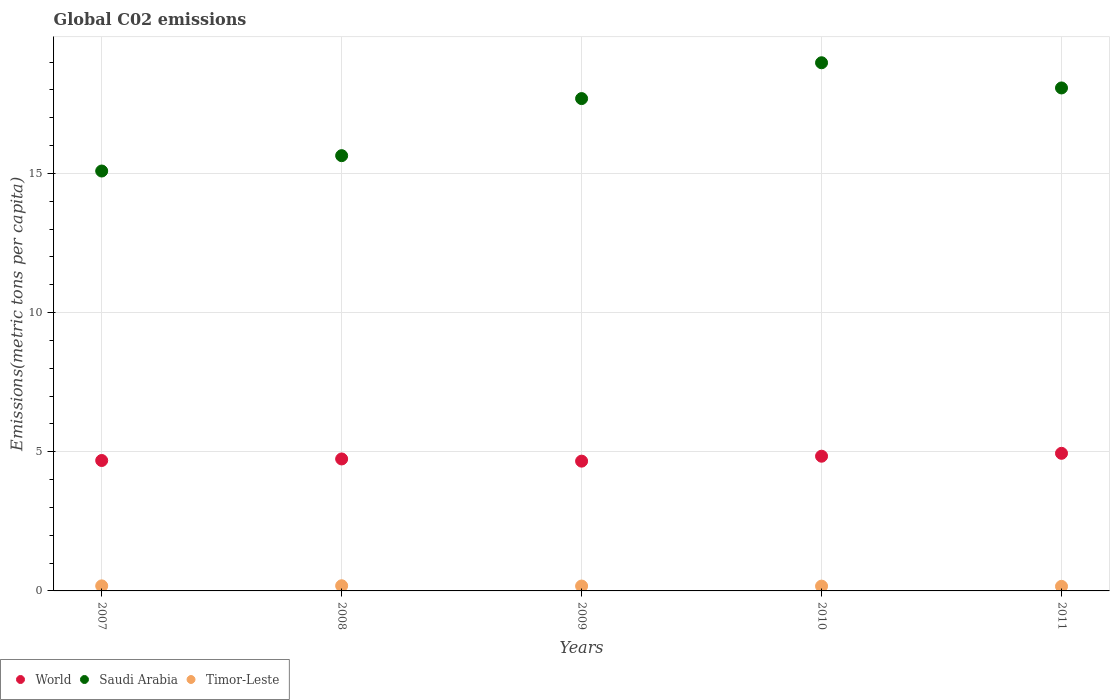How many different coloured dotlines are there?
Offer a very short reply. 3. Is the number of dotlines equal to the number of legend labels?
Make the answer very short. Yes. What is the amount of CO2 emitted in in World in 2009?
Give a very brief answer. 4.66. Across all years, what is the maximum amount of CO2 emitted in in World?
Ensure brevity in your answer.  4.94. Across all years, what is the minimum amount of CO2 emitted in in Saudi Arabia?
Your answer should be compact. 15.09. What is the total amount of CO2 emitted in in World in the graph?
Give a very brief answer. 23.88. What is the difference between the amount of CO2 emitted in in Saudi Arabia in 2007 and that in 2009?
Provide a succinct answer. -2.6. What is the difference between the amount of CO2 emitted in in Saudi Arabia in 2011 and the amount of CO2 emitted in in Timor-Leste in 2007?
Your answer should be compact. 17.89. What is the average amount of CO2 emitted in in Saudi Arabia per year?
Provide a short and direct response. 17.09. In the year 2007, what is the difference between the amount of CO2 emitted in in Saudi Arabia and amount of CO2 emitted in in Timor-Leste?
Offer a terse response. 14.91. In how many years, is the amount of CO2 emitted in in World greater than 4 metric tons per capita?
Your answer should be compact. 5. What is the ratio of the amount of CO2 emitted in in Saudi Arabia in 2008 to that in 2009?
Your answer should be very brief. 0.88. What is the difference between the highest and the second highest amount of CO2 emitted in in World?
Your answer should be very brief. 0.1. What is the difference between the highest and the lowest amount of CO2 emitted in in Timor-Leste?
Keep it short and to the point. 0.02. How many dotlines are there?
Your response must be concise. 3. Are the values on the major ticks of Y-axis written in scientific E-notation?
Make the answer very short. No. Does the graph contain any zero values?
Give a very brief answer. No. Does the graph contain grids?
Ensure brevity in your answer.  Yes. How many legend labels are there?
Offer a terse response. 3. How are the legend labels stacked?
Your answer should be compact. Horizontal. What is the title of the graph?
Your response must be concise. Global C02 emissions. What is the label or title of the X-axis?
Offer a terse response. Years. What is the label or title of the Y-axis?
Offer a very short reply. Emissions(metric tons per capita). What is the Emissions(metric tons per capita) in World in 2007?
Offer a terse response. 4.69. What is the Emissions(metric tons per capita) of Saudi Arabia in 2007?
Your answer should be compact. 15.09. What is the Emissions(metric tons per capita) in Timor-Leste in 2007?
Provide a succinct answer. 0.18. What is the Emissions(metric tons per capita) of World in 2008?
Offer a very short reply. 4.74. What is the Emissions(metric tons per capita) of Saudi Arabia in 2008?
Make the answer very short. 15.64. What is the Emissions(metric tons per capita) in Timor-Leste in 2008?
Offer a terse response. 0.19. What is the Emissions(metric tons per capita) of World in 2009?
Provide a short and direct response. 4.66. What is the Emissions(metric tons per capita) in Saudi Arabia in 2009?
Provide a short and direct response. 17.69. What is the Emissions(metric tons per capita) of Timor-Leste in 2009?
Keep it short and to the point. 0.17. What is the Emissions(metric tons per capita) in World in 2010?
Give a very brief answer. 4.84. What is the Emissions(metric tons per capita) of Saudi Arabia in 2010?
Ensure brevity in your answer.  18.98. What is the Emissions(metric tons per capita) in Timor-Leste in 2010?
Your answer should be compact. 0.17. What is the Emissions(metric tons per capita) of World in 2011?
Your answer should be compact. 4.94. What is the Emissions(metric tons per capita) in Saudi Arabia in 2011?
Offer a very short reply. 18.07. What is the Emissions(metric tons per capita) of Timor-Leste in 2011?
Ensure brevity in your answer.  0.16. Across all years, what is the maximum Emissions(metric tons per capita) in World?
Provide a short and direct response. 4.94. Across all years, what is the maximum Emissions(metric tons per capita) in Saudi Arabia?
Offer a terse response. 18.98. Across all years, what is the maximum Emissions(metric tons per capita) in Timor-Leste?
Provide a short and direct response. 0.19. Across all years, what is the minimum Emissions(metric tons per capita) of World?
Make the answer very short. 4.66. Across all years, what is the minimum Emissions(metric tons per capita) of Saudi Arabia?
Keep it short and to the point. 15.09. Across all years, what is the minimum Emissions(metric tons per capita) of Timor-Leste?
Ensure brevity in your answer.  0.16. What is the total Emissions(metric tons per capita) of World in the graph?
Keep it short and to the point. 23.88. What is the total Emissions(metric tons per capita) of Saudi Arabia in the graph?
Your answer should be very brief. 85.47. What is the total Emissions(metric tons per capita) of Timor-Leste in the graph?
Give a very brief answer. 0.88. What is the difference between the Emissions(metric tons per capita) of World in 2007 and that in 2008?
Your response must be concise. -0.06. What is the difference between the Emissions(metric tons per capita) of Saudi Arabia in 2007 and that in 2008?
Provide a succinct answer. -0.55. What is the difference between the Emissions(metric tons per capita) in Timor-Leste in 2007 and that in 2008?
Offer a terse response. -0. What is the difference between the Emissions(metric tons per capita) in World in 2007 and that in 2009?
Give a very brief answer. 0.02. What is the difference between the Emissions(metric tons per capita) of Saudi Arabia in 2007 and that in 2009?
Give a very brief answer. -2.6. What is the difference between the Emissions(metric tons per capita) in Timor-Leste in 2007 and that in 2009?
Make the answer very short. 0.01. What is the difference between the Emissions(metric tons per capita) in World in 2007 and that in 2010?
Offer a terse response. -0.15. What is the difference between the Emissions(metric tons per capita) of Saudi Arabia in 2007 and that in 2010?
Give a very brief answer. -3.89. What is the difference between the Emissions(metric tons per capita) of Timor-Leste in 2007 and that in 2010?
Provide a short and direct response. 0.01. What is the difference between the Emissions(metric tons per capita) of World in 2007 and that in 2011?
Make the answer very short. -0.26. What is the difference between the Emissions(metric tons per capita) of Saudi Arabia in 2007 and that in 2011?
Provide a succinct answer. -2.98. What is the difference between the Emissions(metric tons per capita) of Timor-Leste in 2007 and that in 2011?
Provide a succinct answer. 0.02. What is the difference between the Emissions(metric tons per capita) in World in 2008 and that in 2009?
Offer a very short reply. 0.08. What is the difference between the Emissions(metric tons per capita) in Saudi Arabia in 2008 and that in 2009?
Give a very brief answer. -2.05. What is the difference between the Emissions(metric tons per capita) in Timor-Leste in 2008 and that in 2009?
Your answer should be very brief. 0.01. What is the difference between the Emissions(metric tons per capita) of World in 2008 and that in 2010?
Ensure brevity in your answer.  -0.1. What is the difference between the Emissions(metric tons per capita) in Saudi Arabia in 2008 and that in 2010?
Your answer should be very brief. -3.34. What is the difference between the Emissions(metric tons per capita) of Timor-Leste in 2008 and that in 2010?
Offer a very short reply. 0.01. What is the difference between the Emissions(metric tons per capita) in World in 2008 and that in 2011?
Make the answer very short. -0.2. What is the difference between the Emissions(metric tons per capita) of Saudi Arabia in 2008 and that in 2011?
Offer a very short reply. -2.43. What is the difference between the Emissions(metric tons per capita) in Timor-Leste in 2008 and that in 2011?
Keep it short and to the point. 0.02. What is the difference between the Emissions(metric tons per capita) of World in 2009 and that in 2010?
Ensure brevity in your answer.  -0.18. What is the difference between the Emissions(metric tons per capita) of Saudi Arabia in 2009 and that in 2010?
Provide a short and direct response. -1.29. What is the difference between the Emissions(metric tons per capita) in Timor-Leste in 2009 and that in 2010?
Your answer should be compact. 0. What is the difference between the Emissions(metric tons per capita) of World in 2009 and that in 2011?
Provide a succinct answer. -0.28. What is the difference between the Emissions(metric tons per capita) of Saudi Arabia in 2009 and that in 2011?
Your response must be concise. -0.38. What is the difference between the Emissions(metric tons per capita) of Timor-Leste in 2009 and that in 2011?
Make the answer very short. 0.01. What is the difference between the Emissions(metric tons per capita) in World in 2010 and that in 2011?
Offer a very short reply. -0.1. What is the difference between the Emissions(metric tons per capita) in Saudi Arabia in 2010 and that in 2011?
Ensure brevity in your answer.  0.91. What is the difference between the Emissions(metric tons per capita) in Timor-Leste in 2010 and that in 2011?
Make the answer very short. 0.01. What is the difference between the Emissions(metric tons per capita) in World in 2007 and the Emissions(metric tons per capita) in Saudi Arabia in 2008?
Give a very brief answer. -10.95. What is the difference between the Emissions(metric tons per capita) in World in 2007 and the Emissions(metric tons per capita) in Timor-Leste in 2008?
Your response must be concise. 4.5. What is the difference between the Emissions(metric tons per capita) in Saudi Arabia in 2007 and the Emissions(metric tons per capita) in Timor-Leste in 2008?
Your response must be concise. 14.9. What is the difference between the Emissions(metric tons per capita) of World in 2007 and the Emissions(metric tons per capita) of Saudi Arabia in 2009?
Make the answer very short. -13. What is the difference between the Emissions(metric tons per capita) in World in 2007 and the Emissions(metric tons per capita) in Timor-Leste in 2009?
Provide a short and direct response. 4.51. What is the difference between the Emissions(metric tons per capita) in Saudi Arabia in 2007 and the Emissions(metric tons per capita) in Timor-Leste in 2009?
Keep it short and to the point. 14.91. What is the difference between the Emissions(metric tons per capita) of World in 2007 and the Emissions(metric tons per capita) of Saudi Arabia in 2010?
Make the answer very short. -14.29. What is the difference between the Emissions(metric tons per capita) of World in 2007 and the Emissions(metric tons per capita) of Timor-Leste in 2010?
Provide a succinct answer. 4.51. What is the difference between the Emissions(metric tons per capita) in Saudi Arabia in 2007 and the Emissions(metric tons per capita) in Timor-Leste in 2010?
Your response must be concise. 14.92. What is the difference between the Emissions(metric tons per capita) in World in 2007 and the Emissions(metric tons per capita) in Saudi Arabia in 2011?
Your response must be concise. -13.39. What is the difference between the Emissions(metric tons per capita) in World in 2007 and the Emissions(metric tons per capita) in Timor-Leste in 2011?
Ensure brevity in your answer.  4.52. What is the difference between the Emissions(metric tons per capita) of Saudi Arabia in 2007 and the Emissions(metric tons per capita) of Timor-Leste in 2011?
Ensure brevity in your answer.  14.92. What is the difference between the Emissions(metric tons per capita) in World in 2008 and the Emissions(metric tons per capita) in Saudi Arabia in 2009?
Make the answer very short. -12.95. What is the difference between the Emissions(metric tons per capita) of World in 2008 and the Emissions(metric tons per capita) of Timor-Leste in 2009?
Ensure brevity in your answer.  4.57. What is the difference between the Emissions(metric tons per capita) in Saudi Arabia in 2008 and the Emissions(metric tons per capita) in Timor-Leste in 2009?
Ensure brevity in your answer.  15.46. What is the difference between the Emissions(metric tons per capita) of World in 2008 and the Emissions(metric tons per capita) of Saudi Arabia in 2010?
Your answer should be very brief. -14.24. What is the difference between the Emissions(metric tons per capita) of World in 2008 and the Emissions(metric tons per capita) of Timor-Leste in 2010?
Make the answer very short. 4.57. What is the difference between the Emissions(metric tons per capita) in Saudi Arabia in 2008 and the Emissions(metric tons per capita) in Timor-Leste in 2010?
Make the answer very short. 15.47. What is the difference between the Emissions(metric tons per capita) of World in 2008 and the Emissions(metric tons per capita) of Saudi Arabia in 2011?
Your answer should be compact. -13.33. What is the difference between the Emissions(metric tons per capita) of World in 2008 and the Emissions(metric tons per capita) of Timor-Leste in 2011?
Offer a terse response. 4.58. What is the difference between the Emissions(metric tons per capita) in Saudi Arabia in 2008 and the Emissions(metric tons per capita) in Timor-Leste in 2011?
Your answer should be compact. 15.48. What is the difference between the Emissions(metric tons per capita) in World in 2009 and the Emissions(metric tons per capita) in Saudi Arabia in 2010?
Your answer should be compact. -14.31. What is the difference between the Emissions(metric tons per capita) of World in 2009 and the Emissions(metric tons per capita) of Timor-Leste in 2010?
Your answer should be very brief. 4.49. What is the difference between the Emissions(metric tons per capita) of Saudi Arabia in 2009 and the Emissions(metric tons per capita) of Timor-Leste in 2010?
Provide a short and direct response. 17.52. What is the difference between the Emissions(metric tons per capita) in World in 2009 and the Emissions(metric tons per capita) in Saudi Arabia in 2011?
Your answer should be very brief. -13.41. What is the difference between the Emissions(metric tons per capita) in World in 2009 and the Emissions(metric tons per capita) in Timor-Leste in 2011?
Make the answer very short. 4.5. What is the difference between the Emissions(metric tons per capita) in Saudi Arabia in 2009 and the Emissions(metric tons per capita) in Timor-Leste in 2011?
Your answer should be very brief. 17.53. What is the difference between the Emissions(metric tons per capita) of World in 2010 and the Emissions(metric tons per capita) of Saudi Arabia in 2011?
Ensure brevity in your answer.  -13.23. What is the difference between the Emissions(metric tons per capita) in World in 2010 and the Emissions(metric tons per capita) in Timor-Leste in 2011?
Make the answer very short. 4.68. What is the difference between the Emissions(metric tons per capita) of Saudi Arabia in 2010 and the Emissions(metric tons per capita) of Timor-Leste in 2011?
Provide a short and direct response. 18.81. What is the average Emissions(metric tons per capita) in World per year?
Your response must be concise. 4.78. What is the average Emissions(metric tons per capita) in Saudi Arabia per year?
Keep it short and to the point. 17.09. What is the average Emissions(metric tons per capita) in Timor-Leste per year?
Give a very brief answer. 0.18. In the year 2007, what is the difference between the Emissions(metric tons per capita) of World and Emissions(metric tons per capita) of Saudi Arabia?
Offer a very short reply. -10.4. In the year 2007, what is the difference between the Emissions(metric tons per capita) of World and Emissions(metric tons per capita) of Timor-Leste?
Provide a succinct answer. 4.51. In the year 2007, what is the difference between the Emissions(metric tons per capita) in Saudi Arabia and Emissions(metric tons per capita) in Timor-Leste?
Keep it short and to the point. 14.91. In the year 2008, what is the difference between the Emissions(metric tons per capita) of World and Emissions(metric tons per capita) of Saudi Arabia?
Your answer should be compact. -10.9. In the year 2008, what is the difference between the Emissions(metric tons per capita) of World and Emissions(metric tons per capita) of Timor-Leste?
Make the answer very short. 4.56. In the year 2008, what is the difference between the Emissions(metric tons per capita) in Saudi Arabia and Emissions(metric tons per capita) in Timor-Leste?
Ensure brevity in your answer.  15.45. In the year 2009, what is the difference between the Emissions(metric tons per capita) in World and Emissions(metric tons per capita) in Saudi Arabia?
Provide a short and direct response. -13.03. In the year 2009, what is the difference between the Emissions(metric tons per capita) of World and Emissions(metric tons per capita) of Timor-Leste?
Give a very brief answer. 4.49. In the year 2009, what is the difference between the Emissions(metric tons per capita) of Saudi Arabia and Emissions(metric tons per capita) of Timor-Leste?
Give a very brief answer. 17.52. In the year 2010, what is the difference between the Emissions(metric tons per capita) of World and Emissions(metric tons per capita) of Saudi Arabia?
Keep it short and to the point. -14.14. In the year 2010, what is the difference between the Emissions(metric tons per capita) in World and Emissions(metric tons per capita) in Timor-Leste?
Your response must be concise. 4.67. In the year 2010, what is the difference between the Emissions(metric tons per capita) in Saudi Arabia and Emissions(metric tons per capita) in Timor-Leste?
Offer a terse response. 18.81. In the year 2011, what is the difference between the Emissions(metric tons per capita) in World and Emissions(metric tons per capita) in Saudi Arabia?
Offer a very short reply. -13.13. In the year 2011, what is the difference between the Emissions(metric tons per capita) in World and Emissions(metric tons per capita) in Timor-Leste?
Ensure brevity in your answer.  4.78. In the year 2011, what is the difference between the Emissions(metric tons per capita) in Saudi Arabia and Emissions(metric tons per capita) in Timor-Leste?
Provide a succinct answer. 17.91. What is the ratio of the Emissions(metric tons per capita) in World in 2007 to that in 2008?
Ensure brevity in your answer.  0.99. What is the ratio of the Emissions(metric tons per capita) in Saudi Arabia in 2007 to that in 2008?
Offer a terse response. 0.96. What is the ratio of the Emissions(metric tons per capita) of Timor-Leste in 2007 to that in 2008?
Ensure brevity in your answer.  0.98. What is the ratio of the Emissions(metric tons per capita) in World in 2007 to that in 2009?
Give a very brief answer. 1. What is the ratio of the Emissions(metric tons per capita) of Saudi Arabia in 2007 to that in 2009?
Make the answer very short. 0.85. What is the ratio of the Emissions(metric tons per capita) in Timor-Leste in 2007 to that in 2009?
Keep it short and to the point. 1.03. What is the ratio of the Emissions(metric tons per capita) in World in 2007 to that in 2010?
Your answer should be compact. 0.97. What is the ratio of the Emissions(metric tons per capita) in Saudi Arabia in 2007 to that in 2010?
Give a very brief answer. 0.8. What is the ratio of the Emissions(metric tons per capita) of Timor-Leste in 2007 to that in 2010?
Ensure brevity in your answer.  1.05. What is the ratio of the Emissions(metric tons per capita) in World in 2007 to that in 2011?
Offer a terse response. 0.95. What is the ratio of the Emissions(metric tons per capita) of Saudi Arabia in 2007 to that in 2011?
Keep it short and to the point. 0.83. What is the ratio of the Emissions(metric tons per capita) of Timor-Leste in 2007 to that in 2011?
Give a very brief answer. 1.11. What is the ratio of the Emissions(metric tons per capita) of World in 2008 to that in 2009?
Your answer should be compact. 1.02. What is the ratio of the Emissions(metric tons per capita) of Saudi Arabia in 2008 to that in 2009?
Offer a very short reply. 0.88. What is the ratio of the Emissions(metric tons per capita) in Timor-Leste in 2008 to that in 2009?
Offer a very short reply. 1.06. What is the ratio of the Emissions(metric tons per capita) of World in 2008 to that in 2010?
Provide a succinct answer. 0.98. What is the ratio of the Emissions(metric tons per capita) in Saudi Arabia in 2008 to that in 2010?
Ensure brevity in your answer.  0.82. What is the ratio of the Emissions(metric tons per capita) of Timor-Leste in 2008 to that in 2010?
Give a very brief answer. 1.08. What is the ratio of the Emissions(metric tons per capita) in World in 2008 to that in 2011?
Make the answer very short. 0.96. What is the ratio of the Emissions(metric tons per capita) in Saudi Arabia in 2008 to that in 2011?
Your answer should be compact. 0.87. What is the ratio of the Emissions(metric tons per capita) of Timor-Leste in 2008 to that in 2011?
Your response must be concise. 1.13. What is the ratio of the Emissions(metric tons per capita) in World in 2009 to that in 2010?
Provide a succinct answer. 0.96. What is the ratio of the Emissions(metric tons per capita) of Saudi Arabia in 2009 to that in 2010?
Offer a terse response. 0.93. What is the ratio of the Emissions(metric tons per capita) of Timor-Leste in 2009 to that in 2010?
Make the answer very short. 1.02. What is the ratio of the Emissions(metric tons per capita) of World in 2009 to that in 2011?
Make the answer very short. 0.94. What is the ratio of the Emissions(metric tons per capita) of Saudi Arabia in 2009 to that in 2011?
Offer a very short reply. 0.98. What is the ratio of the Emissions(metric tons per capita) in Timor-Leste in 2009 to that in 2011?
Make the answer very short. 1.07. What is the ratio of the Emissions(metric tons per capita) of World in 2010 to that in 2011?
Your response must be concise. 0.98. What is the ratio of the Emissions(metric tons per capita) in Saudi Arabia in 2010 to that in 2011?
Make the answer very short. 1.05. What is the ratio of the Emissions(metric tons per capita) in Timor-Leste in 2010 to that in 2011?
Ensure brevity in your answer.  1.05. What is the difference between the highest and the second highest Emissions(metric tons per capita) in World?
Offer a very short reply. 0.1. What is the difference between the highest and the second highest Emissions(metric tons per capita) in Saudi Arabia?
Give a very brief answer. 0.91. What is the difference between the highest and the second highest Emissions(metric tons per capita) of Timor-Leste?
Your answer should be compact. 0. What is the difference between the highest and the lowest Emissions(metric tons per capita) in World?
Your answer should be compact. 0.28. What is the difference between the highest and the lowest Emissions(metric tons per capita) in Saudi Arabia?
Ensure brevity in your answer.  3.89. What is the difference between the highest and the lowest Emissions(metric tons per capita) of Timor-Leste?
Your answer should be compact. 0.02. 